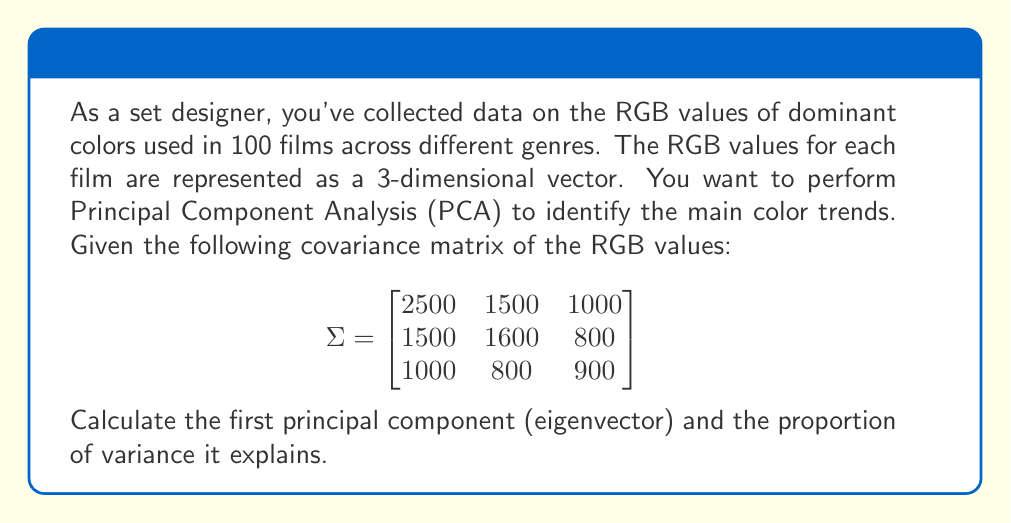Help me with this question. To find the principal components and their explained variance, we need to follow these steps:

1) First, we need to find the eigenvalues of the covariance matrix. The characteristic equation is:

   $$det(\Sigma - \lambda I) = 0$$

2) Expanding this, we get:

   $$(2500-\lambda)(1600-\lambda)(900-\lambda) - 1500^2(900-\lambda) - 1000^2(1600-\lambda) - 800^2(2500-\lambda) + 2(1500)(1000)(800) = 0$$

3) Solving this equation (which is cubic and can be solved using numerical methods), we get the eigenvalues:

   $$\lambda_1 \approx 4115.7, \lambda_2 \approx 707.3, \lambda_3 \approx 177.0$$

4) The first principal component corresponds to the largest eigenvalue, $\lambda_1 \approx 4115.7$. To find its eigenvector, we solve:

   $$(\Sigma - \lambda_1 I)v = 0$$

5) This gives us the eigenvector (normalized):

   $$v_1 \approx [0.707, 0.577, 0.408]^T$$

6) To calculate the proportion of variance explained by the first principal component, we use:

   $$\frac{\lambda_1}{\lambda_1 + \lambda_2 + \lambda_3} \approx \frac{4115.7}{4115.7 + 707.3 + 177.0} \approx 0.823 \text{ or } 82.3\%$$

Therefore, the first principal component is approximately [0.707, 0.577, 0.408] and it explains about 82.3% of the total variance in the data.
Answer: First principal component: [0.707, 0.577, 0.408], Explained variance: 82.3% 